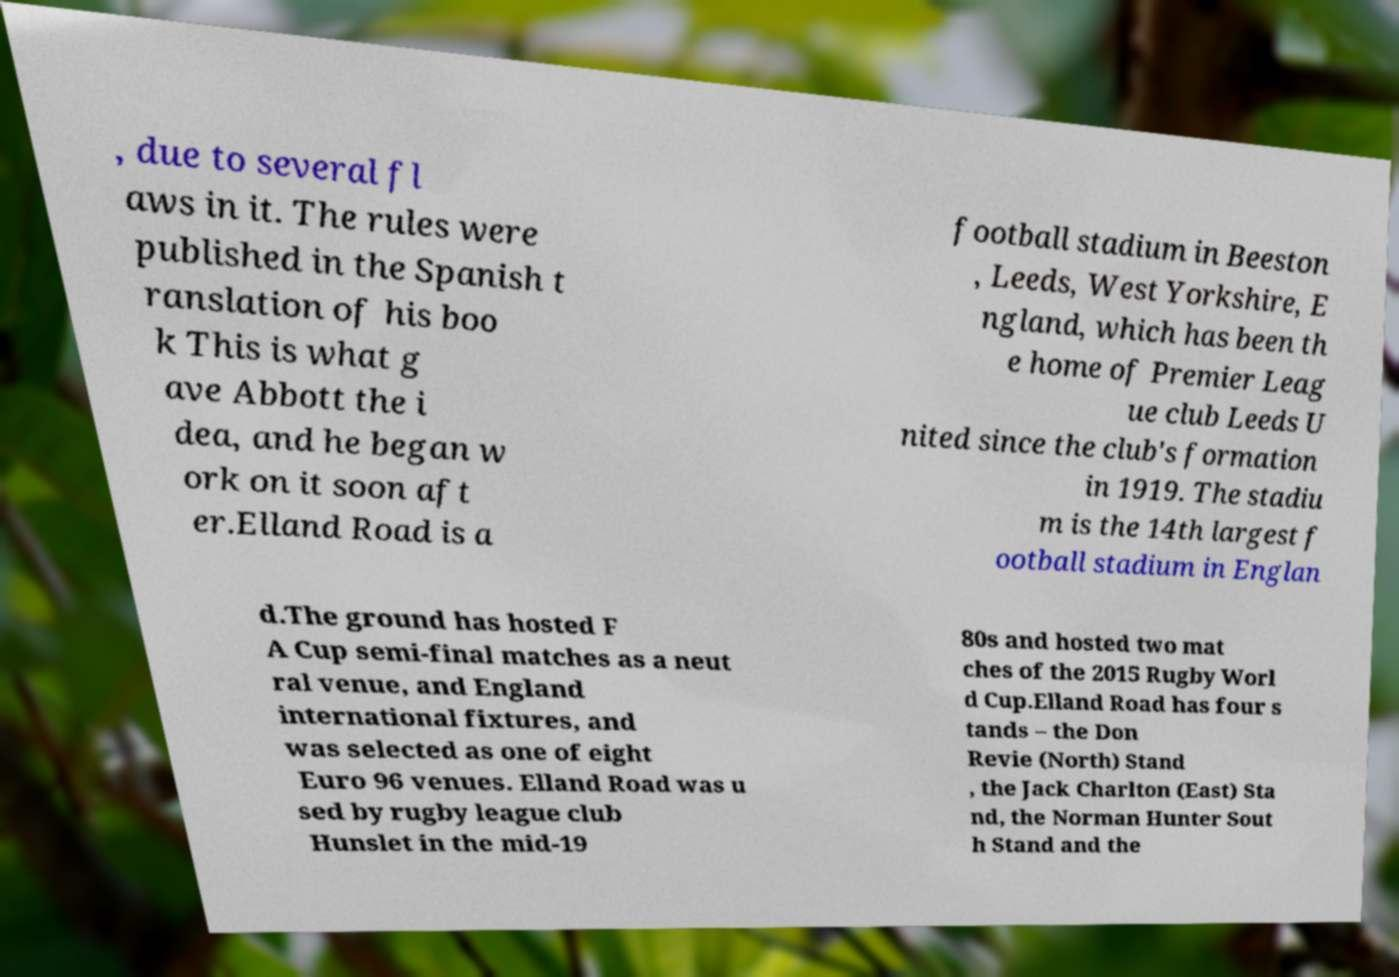Could you assist in decoding the text presented in this image and type it out clearly? , due to several fl aws in it. The rules were published in the Spanish t ranslation of his boo k This is what g ave Abbott the i dea, and he began w ork on it soon aft er.Elland Road is a football stadium in Beeston , Leeds, West Yorkshire, E ngland, which has been th e home of Premier Leag ue club Leeds U nited since the club's formation in 1919. The stadiu m is the 14th largest f ootball stadium in Englan d.The ground has hosted F A Cup semi-final matches as a neut ral venue, and England international fixtures, and was selected as one of eight Euro 96 venues. Elland Road was u sed by rugby league club Hunslet in the mid-19 80s and hosted two mat ches of the 2015 Rugby Worl d Cup.Elland Road has four s tands – the Don Revie (North) Stand , the Jack Charlton (East) Sta nd, the Norman Hunter Sout h Stand and the 